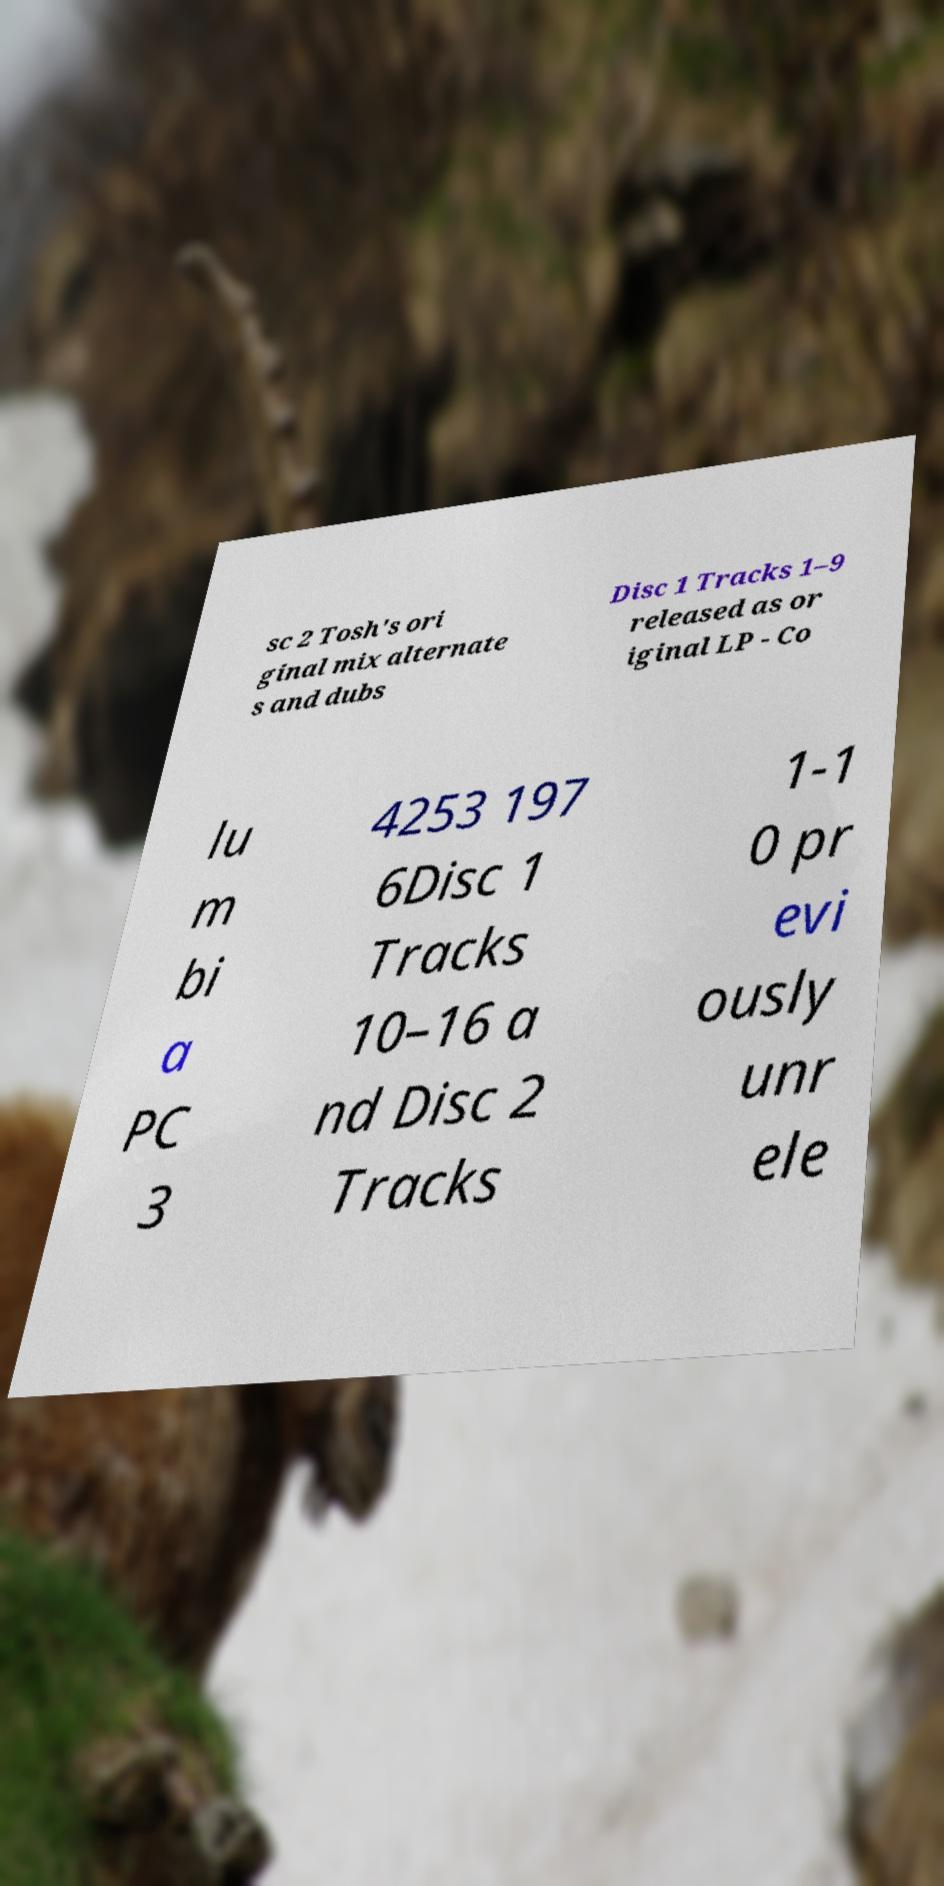Please identify and transcribe the text found in this image. sc 2 Tosh's ori ginal mix alternate s and dubs Disc 1 Tracks 1–9 released as or iginal LP - Co lu m bi a PC 3 4253 197 6Disc 1 Tracks 10–16 a nd Disc 2 Tracks 1-1 0 pr evi ously unr ele 